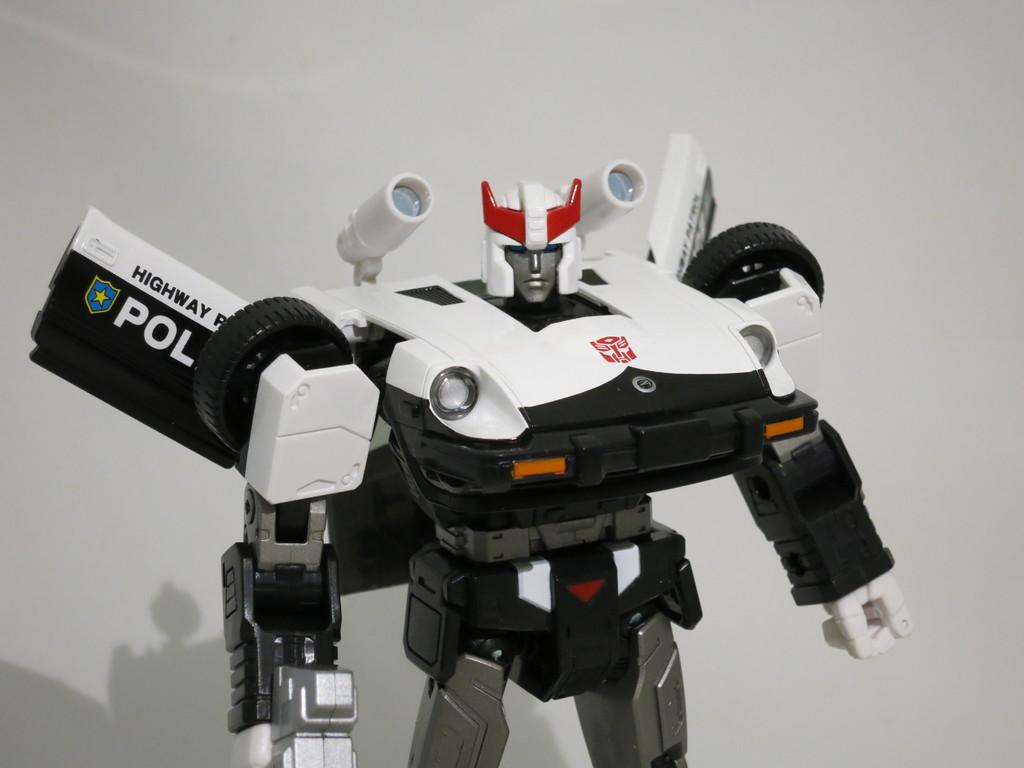What kind of police is this robot for?
Make the answer very short. Highway. 